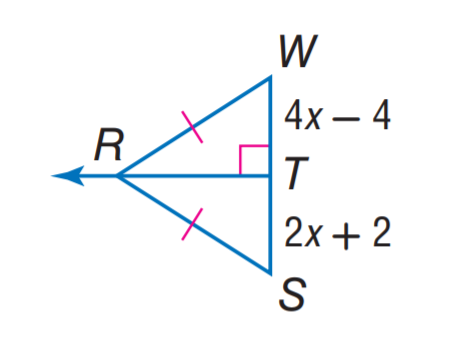Answer the mathemtical geometry problem and directly provide the correct option letter.
Question: Find S W.
Choices: A: 4 B: 8 C: 12 D: 16 D 